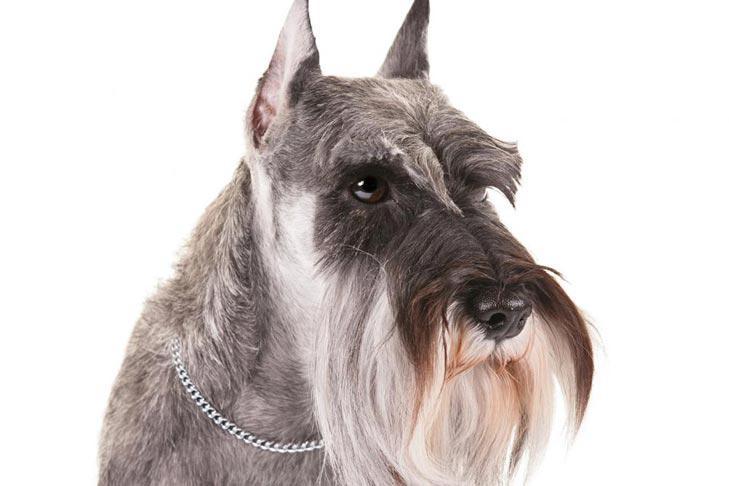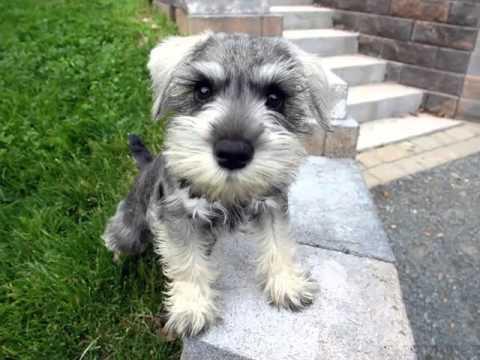The first image is the image on the left, the second image is the image on the right. Examine the images to the left and right. Is the description "An image contains a schnauzer standing and turned leftward." accurate? Answer yes or no. No. 